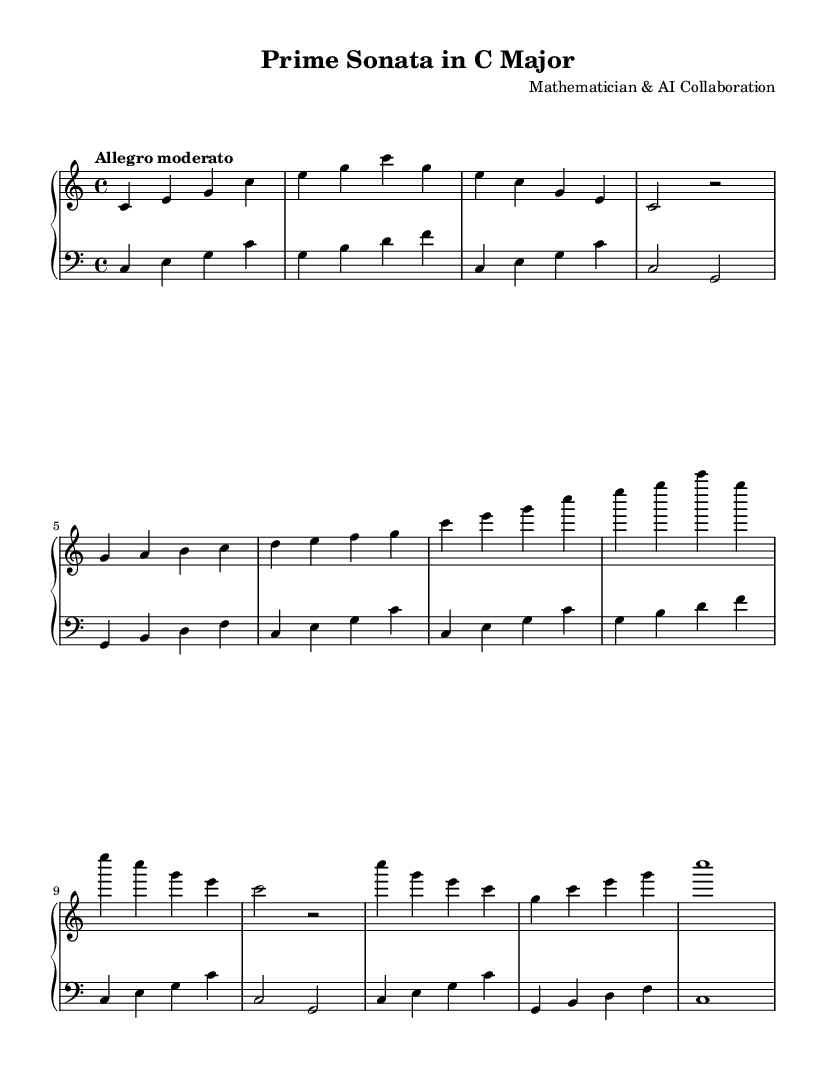What is the key signature of this music? The key signature is indicated in the global section where "c" is shown for C major, meaning there are no sharps or flats.
Answer: C major What is the time signature of this piece? The time signature is displayed in the global section as "4/4", which indicates there are four beats in each measure.
Answer: 4/4 What is the tempo marking? The tempo marking is provided in the global section, which says "Allegro moderato," indicating a moderately fast tempo.
Answer: Allegro moderato How many measures are in the development section? By examining the left-hand and right-hand sections of the music, the development section contains 4 measures in total.
Answer: 4 Which section includes a repeating phrase? The recapitulation section shows repetition of the phrase found in the exposition, as indicated by the same patterns of notes in both sections.
Answer: Recapitulation How many main parts does the sonata have? The structure of the piece can be divided into four main parts: Exposition, Development, Recapitulation, and Coda, all of which can be identified in the music.
Answer: Four What rhythmic pattern is used to represent the prime number sequences? The rhythmic pattern is illustrated in the primeRhythm section, which uses a combination of dotted eighth notes and sixteenth notes to create an irregular yet structured sequence.
Answer: PrimeRhythm 